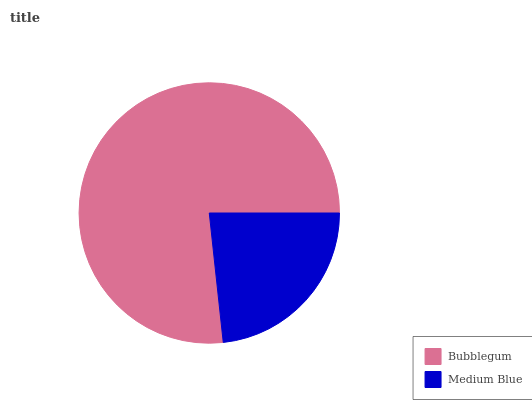Is Medium Blue the minimum?
Answer yes or no. Yes. Is Bubblegum the maximum?
Answer yes or no. Yes. Is Medium Blue the maximum?
Answer yes or no. No. Is Bubblegum greater than Medium Blue?
Answer yes or no. Yes. Is Medium Blue less than Bubblegum?
Answer yes or no. Yes. Is Medium Blue greater than Bubblegum?
Answer yes or no. No. Is Bubblegum less than Medium Blue?
Answer yes or no. No. Is Bubblegum the high median?
Answer yes or no. Yes. Is Medium Blue the low median?
Answer yes or no. Yes. Is Medium Blue the high median?
Answer yes or no. No. Is Bubblegum the low median?
Answer yes or no. No. 